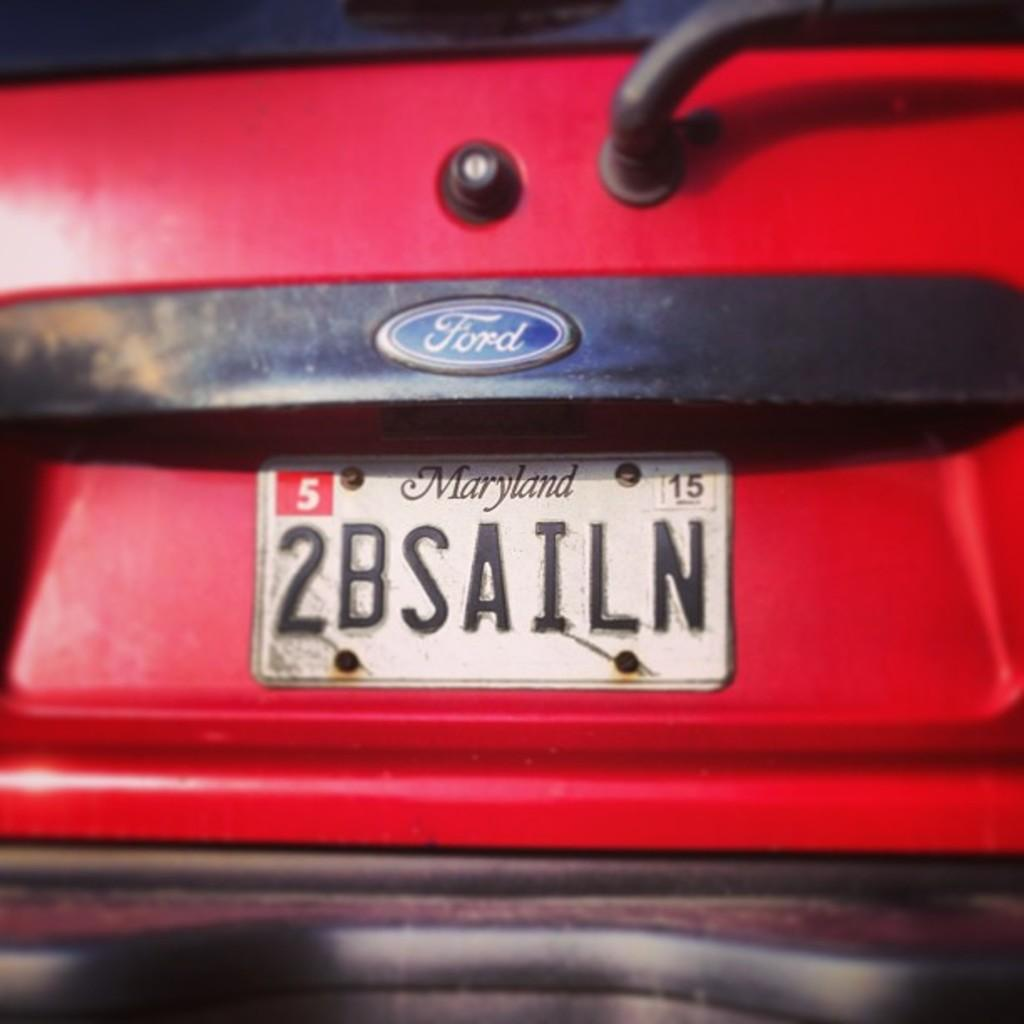What is the main subject of the image? The main subject of the image is a car. Can you describe the color scheme of the car? The car has a red and black color scheme. What is the color of the number plate on the front of the car? The number plate on the front of the car is white. What type of crime is being committed in the image? There is no indication of a crime being committed in the image; it simply shows a car with a red and black color scheme and a white number plate on the front. Can you see any apparatus attached to the car in the image? There is no apparatus visible in the image; it only shows a car with a red and black color scheme and a white number plate on the front. 